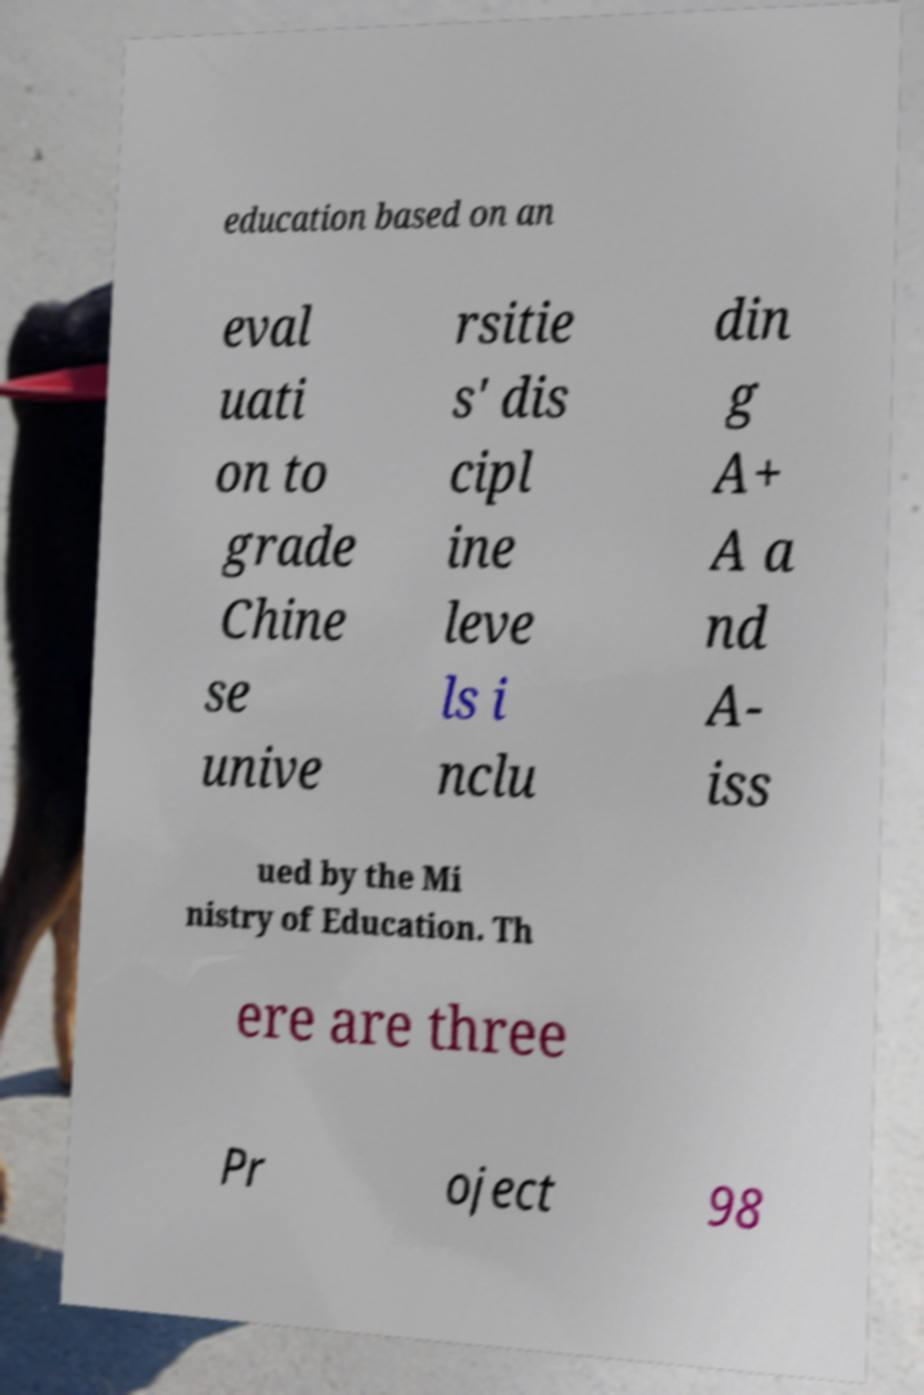Can you read and provide the text displayed in the image?This photo seems to have some interesting text. Can you extract and type it out for me? education based on an eval uati on to grade Chine se unive rsitie s' dis cipl ine leve ls i nclu din g A+ A a nd A- iss ued by the Mi nistry of Education. Th ere are three Pr oject 98 